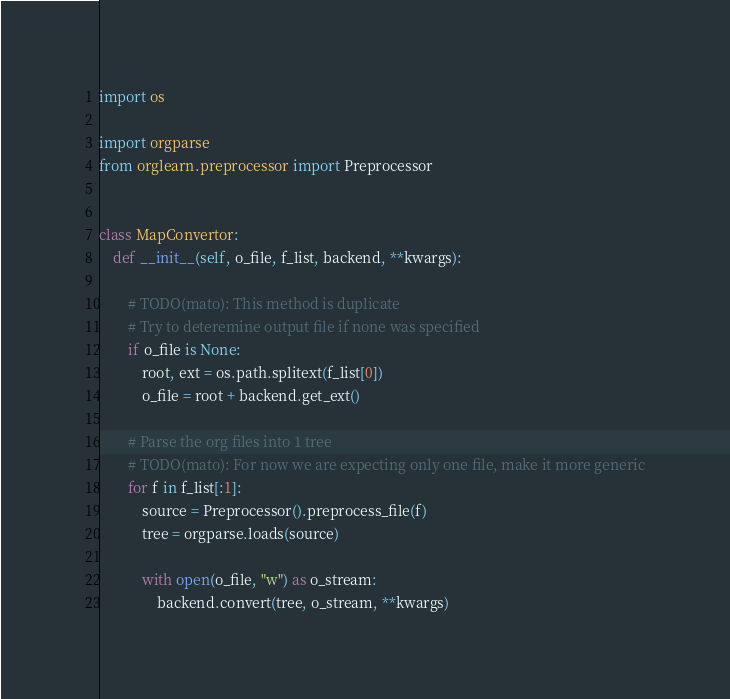Convert code to text. <code><loc_0><loc_0><loc_500><loc_500><_Python_>import os

import orgparse
from orglearn.preprocessor import Preprocessor


class MapConvertor:
    def __init__(self, o_file, f_list, backend, **kwargs):

        # TODO(mato): This method is duplicate
        # Try to deteremine output file if none was specified
        if o_file is None:
            root, ext = os.path.splitext(f_list[0])
            o_file = root + backend.get_ext()

        # Parse the org files into 1 tree
        # TODO(mato): For now we are expecting only one file, make it more generic
        for f in f_list[:1]:
            source = Preprocessor().preprocess_file(f)
            tree = orgparse.loads(source)

            with open(o_file, "w") as o_stream:
                backend.convert(tree, o_stream, **kwargs)
</code> 